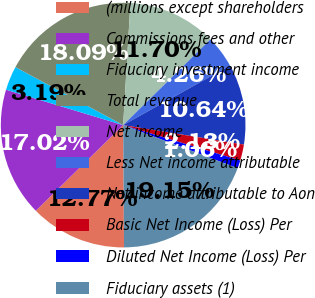Convert chart to OTSL. <chart><loc_0><loc_0><loc_500><loc_500><pie_chart><fcel>(millions except shareholders<fcel>Commissions fees and other<fcel>Fiduciary investment income<fcel>Total revenue<fcel>Net income<fcel>Less Net income attributable<fcel>Net income attributable to Aon<fcel>Basic Net Income (Loss) Per<fcel>Diluted Net Income (Loss) Per<fcel>Fiduciary assets (1)<nl><fcel>12.77%<fcel>17.02%<fcel>3.19%<fcel>18.09%<fcel>11.7%<fcel>4.26%<fcel>10.64%<fcel>2.13%<fcel>1.06%<fcel>19.15%<nl></chart> 